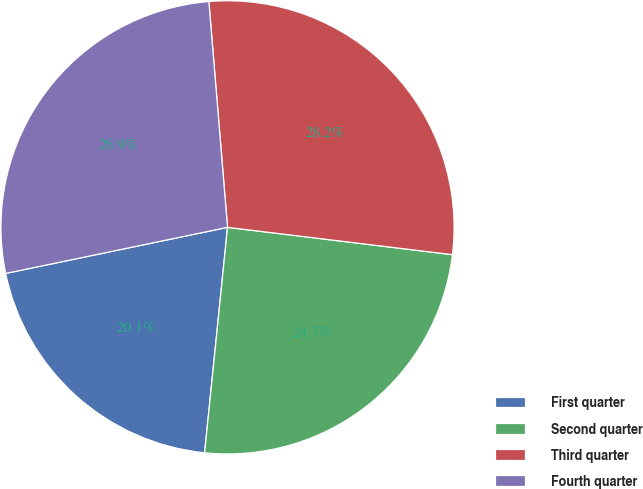<chart> <loc_0><loc_0><loc_500><loc_500><pie_chart><fcel>First quarter<fcel>Second quarter<fcel>Third quarter<fcel>Fourth quarter<nl><fcel>20.13%<fcel>24.69%<fcel>28.24%<fcel>26.95%<nl></chart> 